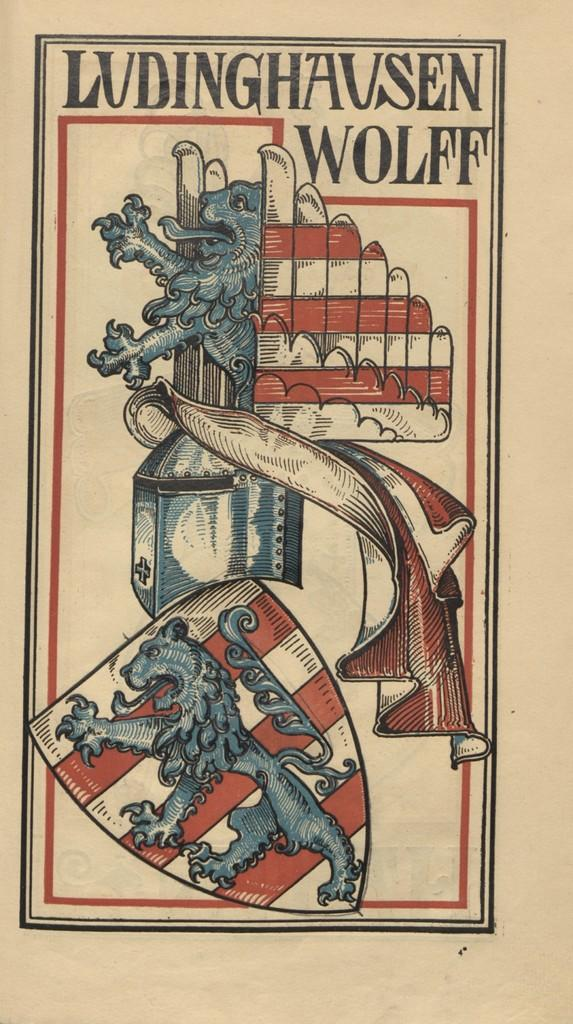What type of visual is the image? The image is a poster. What can be seen on the poster besides text? There are pictures on the poster. What else is featured on the poster besides images? There are letters on the poster. What is the name of the nation depicted in the poster? There is no nation depicted in the poster; it only contains pictures and letters. How many hours are represented in the poster? There is no representation of time or hours in the poster. 